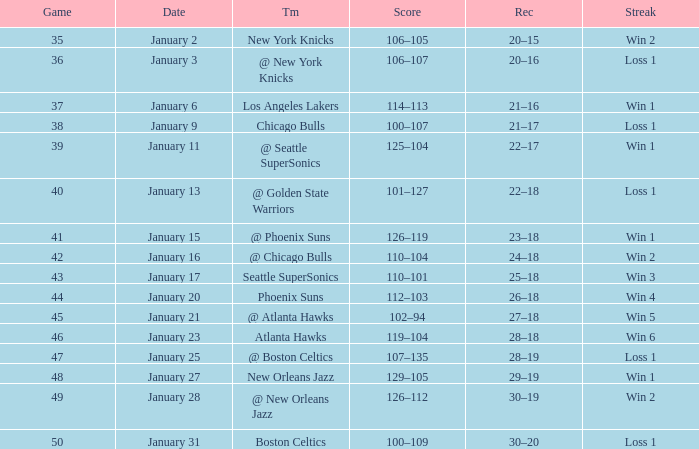What is the Streak in the game with a Record of 20–16? Loss 1. 